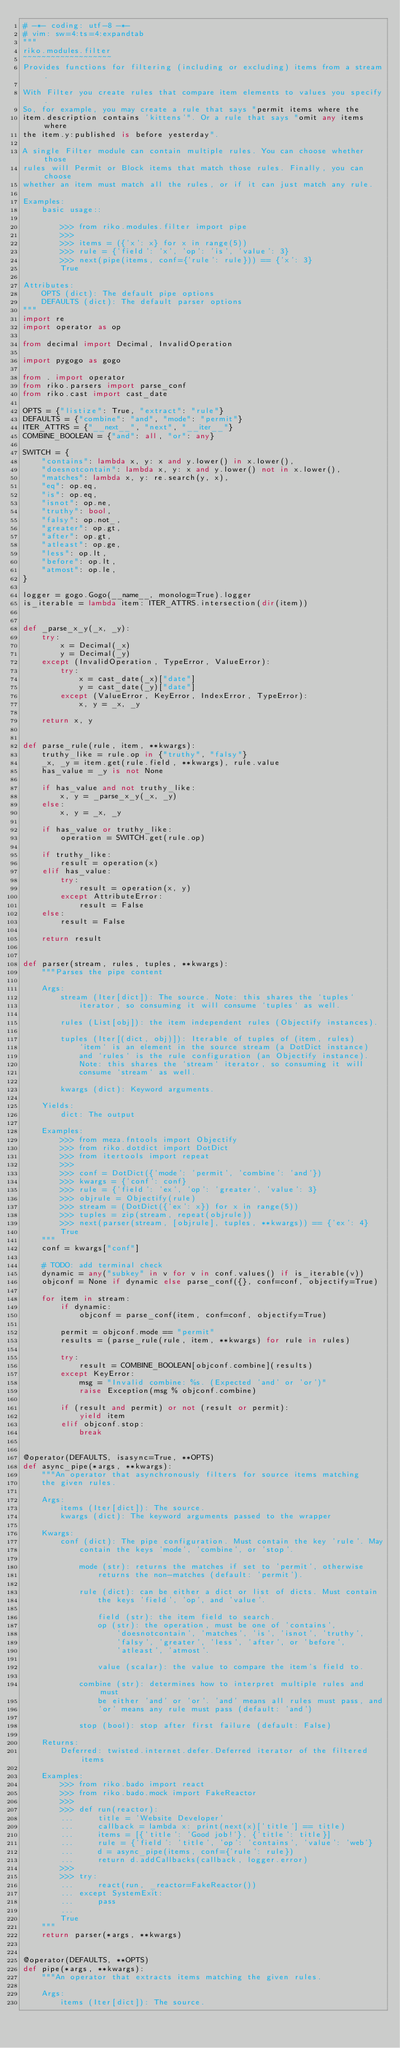Convert code to text. <code><loc_0><loc_0><loc_500><loc_500><_Python_># -*- coding: utf-8 -*-
# vim: sw=4:ts=4:expandtab
"""
riko.modules.filter
~~~~~~~~~~~~~~~~~~~
Provides functions for filtering (including or excluding) items from a stream.

With Filter you create rules that compare item elements to values you specify.
So, for example, you may create a rule that says "permit items where the
item.description contains 'kittens'". Or a rule that says "omit any items where
the item.y:published is before yesterday".

A single Filter module can contain multiple rules. You can choose whether those
rules will Permit or Block items that match those rules. Finally, you can choose
whether an item must match all the rules, or if it can just match any rule.

Examples:
    basic usage::

        >>> from riko.modules.filter import pipe
        >>>
        >>> items = ({'x': x} for x in range(5))
        >>> rule = {'field': 'x', 'op': 'is', 'value': 3}
        >>> next(pipe(items, conf={'rule': rule})) == {'x': 3}
        True

Attributes:
    OPTS (dict): The default pipe options
    DEFAULTS (dict): The default parser options
"""
import re
import operator as op

from decimal import Decimal, InvalidOperation

import pygogo as gogo

from . import operator
from riko.parsers import parse_conf
from riko.cast import cast_date

OPTS = {"listize": True, "extract": "rule"}
DEFAULTS = {"combine": "and", "mode": "permit"}
ITER_ATTRS = {"__next__", "next", "__iter__"}
COMBINE_BOOLEAN = {"and": all, "or": any}

SWITCH = {
    "contains": lambda x, y: x and y.lower() in x.lower(),
    "doesnotcontain": lambda x, y: x and y.lower() not in x.lower(),
    "matches": lambda x, y: re.search(y, x),
    "eq": op.eq,
    "is": op.eq,
    "isnot": op.ne,
    "truthy": bool,
    "falsy": op.not_,
    "greater": op.gt,
    "after": op.gt,
    "atleast": op.ge,
    "less": op.lt,
    "before": op.lt,
    "atmost": op.le,
}

logger = gogo.Gogo(__name__, monolog=True).logger
is_iterable = lambda item: ITER_ATTRS.intersection(dir(item))


def _parse_x_y(_x, _y):
    try:
        x = Decimal(_x)
        y = Decimal(_y)
    except (InvalidOperation, TypeError, ValueError):
        try:
            x = cast_date(_x)["date"]
            y = cast_date(_y)["date"]
        except (ValueError, KeyError, IndexError, TypeError):
            x, y = _x, _y

    return x, y


def parse_rule(rule, item, **kwargs):
    truthy_like = rule.op in {"truthy", "falsy"}
    _x, _y = item.get(rule.field, **kwargs), rule.value
    has_value = _y is not None

    if has_value and not truthy_like:
        x, y = _parse_x_y(_x, _y)
    else:
        x, y = _x, _y

    if has_value or truthy_like:
        operation = SWITCH.get(rule.op)

    if truthy_like:
        result = operation(x)
    elif has_value:
        try:
            result = operation(x, y)
        except AttributeError:
            result = False
    else:
        result = False

    return result


def parser(stream, rules, tuples, **kwargs):
    """Parses the pipe content

    Args:
        stream (Iter[dict]): The source. Note: this shares the `tuples`
            iterator, so consuming it will consume `tuples` as well.

        rules (List[obj]): the item independent rules (Objectify instances).

        tuples (Iter[(dict, obj)]): Iterable of tuples of (item, rules)
            `item` is an element in the source stream (a DotDict instance)
            and `rules` is the rule configuration (an Objectify instance).
            Note: this shares the `stream` iterator, so consuming it will
            consume `stream` as well.

        kwargs (dict): Keyword arguments.

    Yields:
        dict: The output

    Examples:
        >>> from meza.fntools import Objectify
        >>> from riko.dotdict import DotDict
        >>> from itertools import repeat
        >>>
        >>> conf = DotDict({'mode': 'permit', 'combine': 'and'})
        >>> kwargs = {'conf': conf}
        >>> rule = {'field': 'ex', 'op': 'greater', 'value': 3}
        >>> objrule = Objectify(rule)
        >>> stream = (DotDict({'ex': x}) for x in range(5))
        >>> tuples = zip(stream, repeat(objrule))
        >>> next(parser(stream, [objrule], tuples, **kwargs)) == {'ex': 4}
        True
    """
    conf = kwargs["conf"]

    # TODO: add terminal check
    dynamic = any("subkey" in v for v in conf.values() if is_iterable(v))
    objconf = None if dynamic else parse_conf({}, conf=conf, objectify=True)

    for item in stream:
        if dynamic:
            objconf = parse_conf(item, conf=conf, objectify=True)

        permit = objconf.mode == "permit"
        results = (parse_rule(rule, item, **kwargs) for rule in rules)

        try:
            result = COMBINE_BOOLEAN[objconf.combine](results)
        except KeyError:
            msg = "Invalid combine: %s. (Expected 'and' or 'or')"
            raise Exception(msg % objconf.combine)

        if (result and permit) or not (result or permit):
            yield item
        elif objconf.stop:
            break


@operator(DEFAULTS, isasync=True, **OPTS)
def async_pipe(*args, **kwargs):
    """An operator that asynchronously filters for source items matching
    the given rules.

    Args:
        items (Iter[dict]): The source.
        kwargs (dict): The keyword arguments passed to the wrapper

    Kwargs:
        conf (dict): The pipe configuration. Must contain the key 'rule'. May
            contain the keys 'mode', 'combine', or 'stop'.

            mode (str): returns the matches if set to 'permit', otherwise
                returns the non-matches (default: 'permit').

            rule (dict): can be either a dict or list of dicts. Must contain
                the keys 'field', 'op', and 'value'.

                field (str): the item field to search.
                op (str): the operation, must be one of 'contains',
                    'doesnotcontain', 'matches', 'is', 'isnot', 'truthy',
                    'falsy', 'greater', 'less', 'after', or 'before',
                    'atleast', 'atmost'.

                value (scalar): the value to compare the item's field to.

            combine (str): determines how to interpret multiple rules and must
                be either 'and' or 'or'. 'and' means all rules must pass, and
                'or' means any rule must pass (default: 'and')

            stop (bool): stop after first failure (default: False)

    Returns:
        Deferred: twisted.internet.defer.Deferred iterator of the filtered items

    Examples:
        >>> from riko.bado import react
        >>> from riko.bado.mock import FakeReactor
        >>>
        >>> def run(reactor):
        ...     title = 'Website Developer'
        ...     callback = lambda x: print(next(x)['title'] == title)
        ...     items = [{'title': 'Good job!'}, {'title': title}]
        ...     rule = {'field': 'title', 'op': 'contains', 'value': 'web'}
        ...     d = async_pipe(items, conf={'rule': rule})
        ...     return d.addCallbacks(callback, logger.error)
        >>>
        >>> try:
        ...     react(run, _reactor=FakeReactor())
        ... except SystemExit:
        ...     pass
        ...
        True
    """
    return parser(*args, **kwargs)


@operator(DEFAULTS, **OPTS)
def pipe(*args, **kwargs):
    """An operator that extracts items matching the given rules.

    Args:
        items (Iter[dict]): The source.</code> 